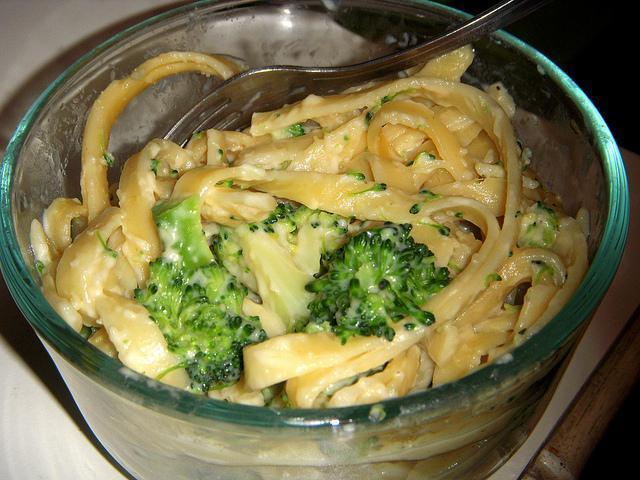How many broccolis can you see?
Give a very brief answer. 2. 